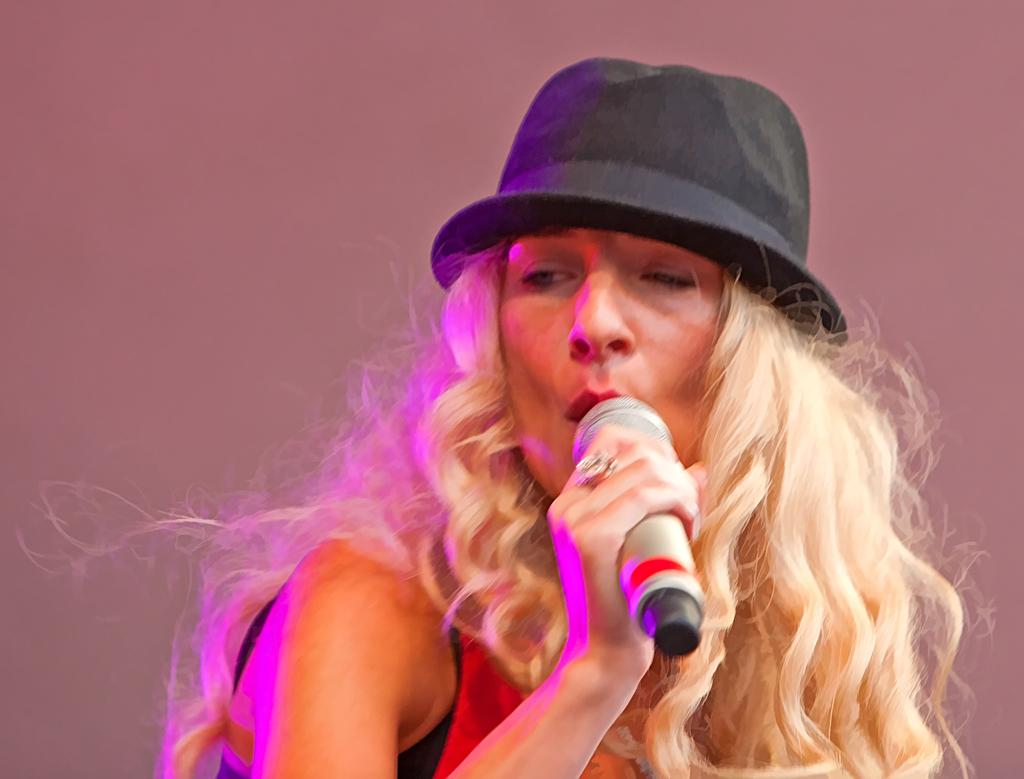Who is the main subject in the image? There is a woman in the image. What is the woman doing in the image? The woman is singing. What object is the woman holding in the image? The woman is holding a microphone. What accessory is the woman wearing in the image? The woman is wearing a cap. What piece of jewelry can be seen on the woman's hand in the image? The woman has a ring on her finger. What does the woman's father say about her singing in the image? There is no mention of the woman's father or any dialogue in the image, so it cannot be determined what he might say about her singing. 